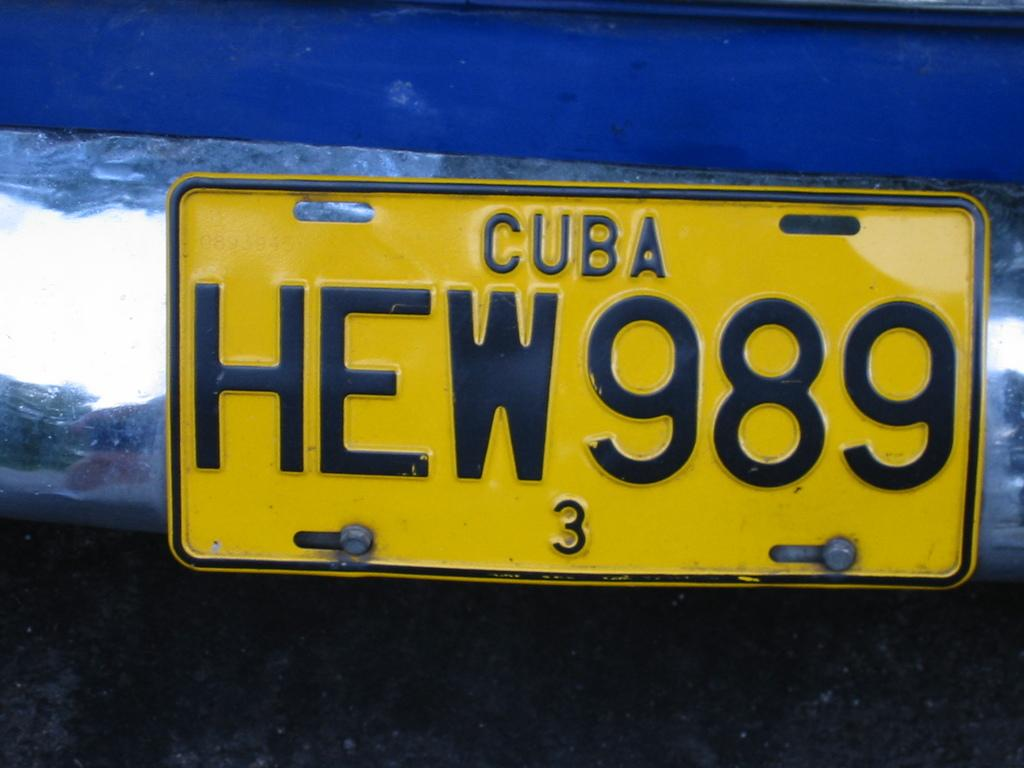<image>
Render a clear and concise summary of the photo. A license plate from Cuba reads HEW989 with a small 3 at the bottom. 